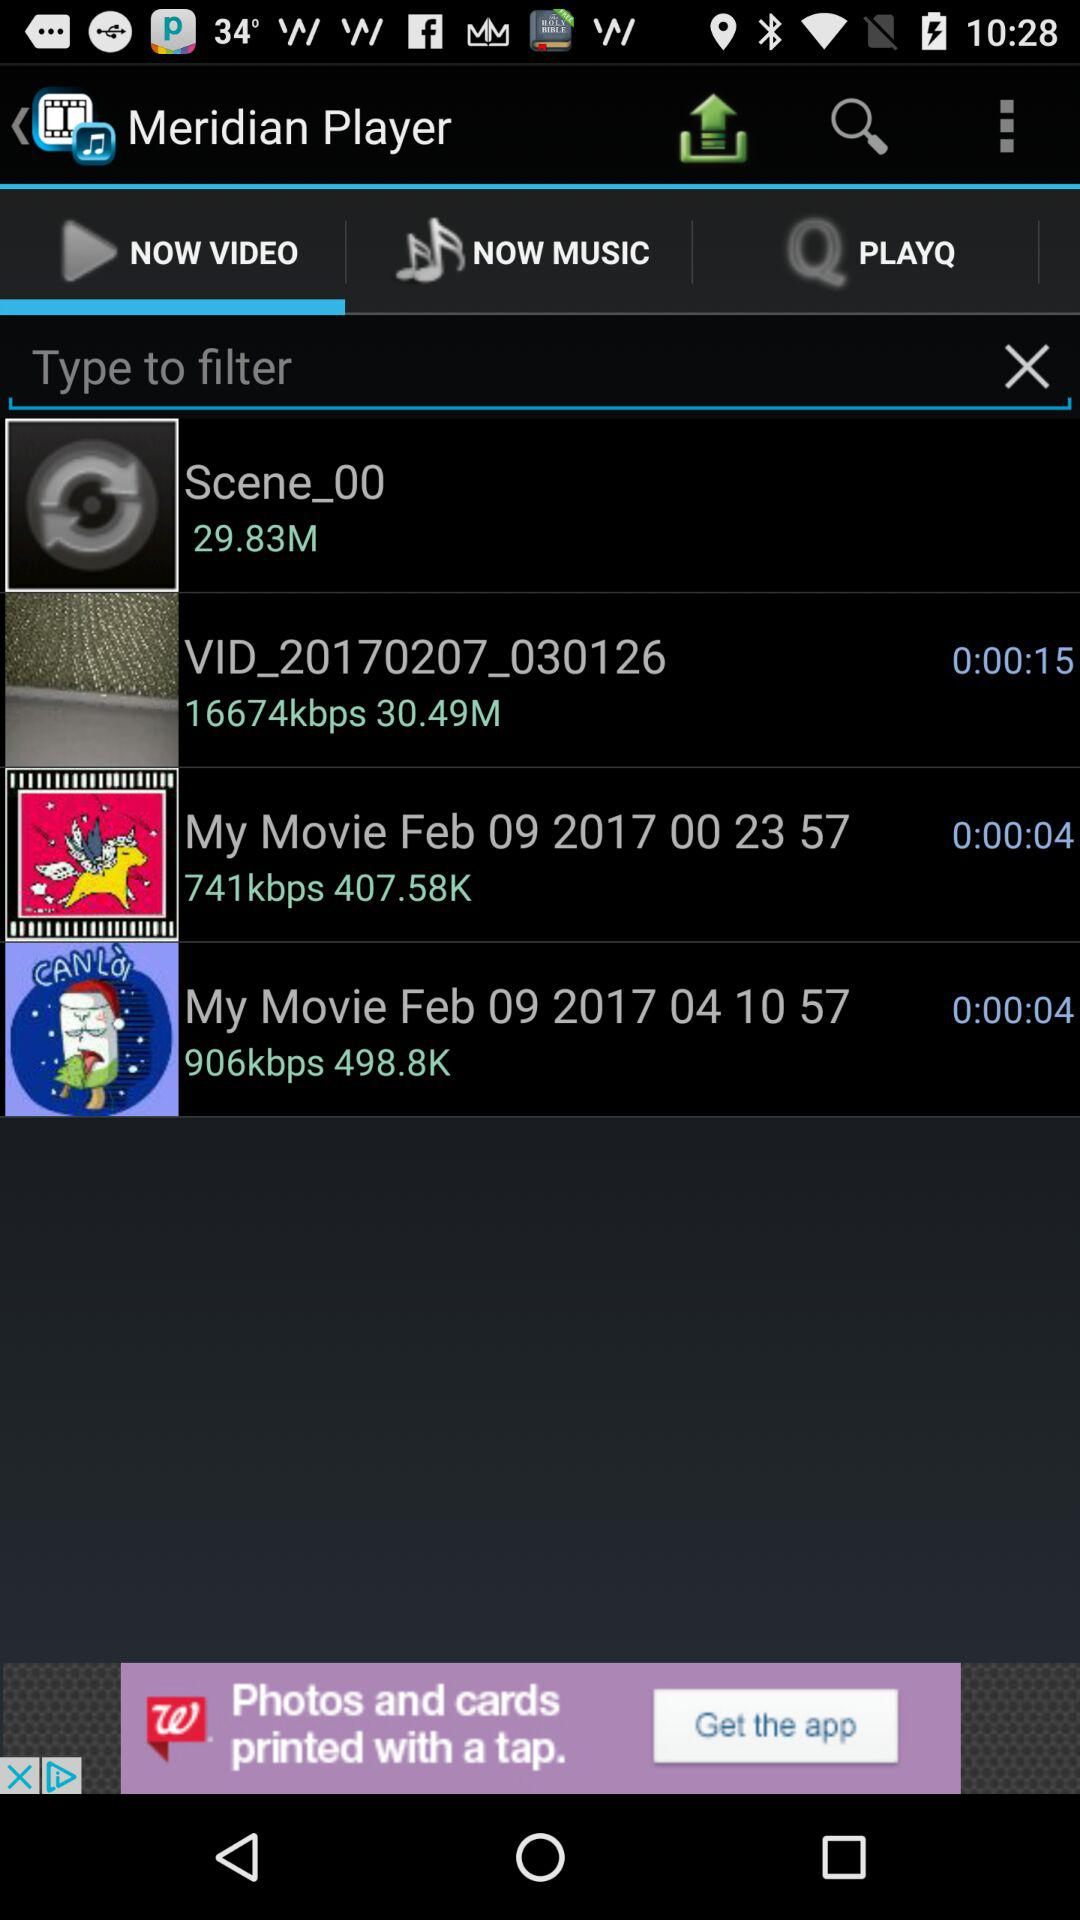Which tab are we on? You are on the "NOW VIDEO" tab. 